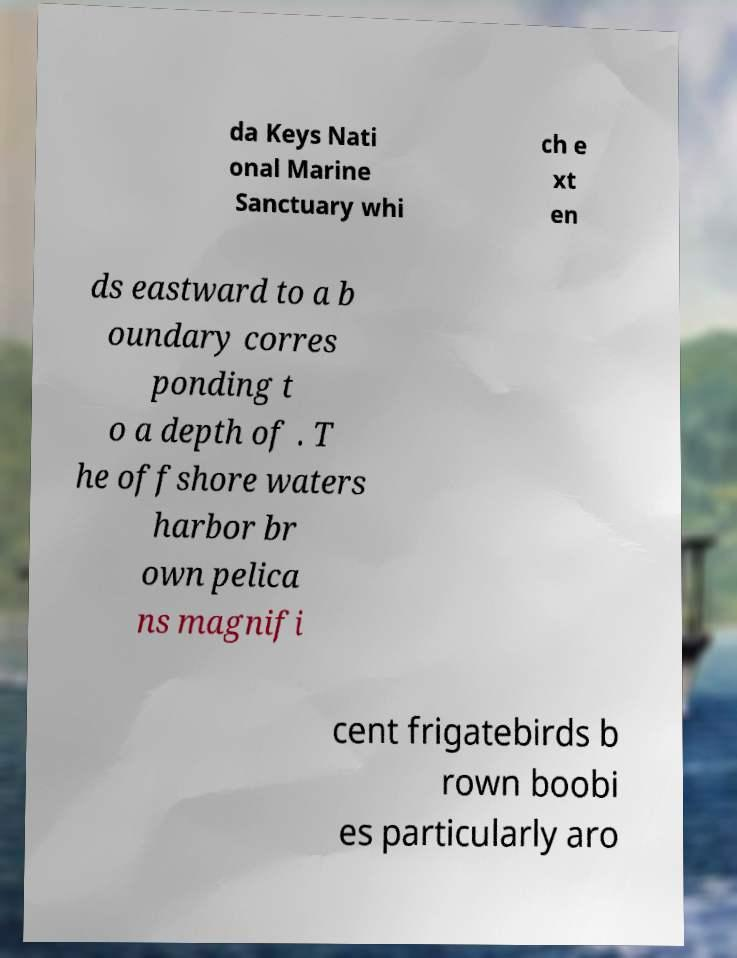I need the written content from this picture converted into text. Can you do that? da Keys Nati onal Marine Sanctuary whi ch e xt en ds eastward to a b oundary corres ponding t o a depth of . T he offshore waters harbor br own pelica ns magnifi cent frigatebirds b rown boobi es particularly aro 